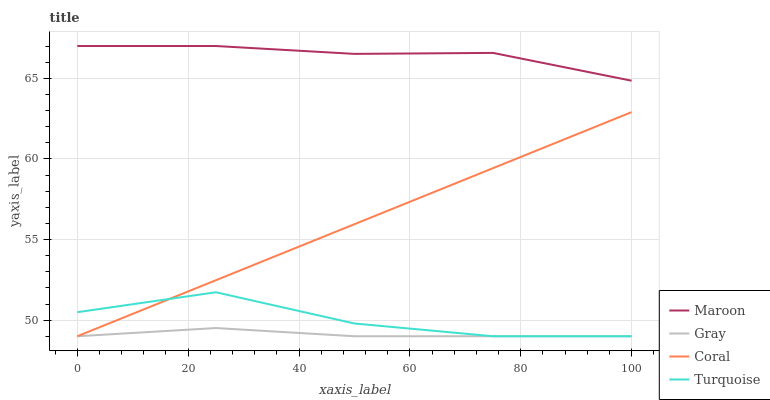Does Gray have the minimum area under the curve?
Answer yes or no. Yes. Does Maroon have the maximum area under the curve?
Answer yes or no. Yes. Does Coral have the minimum area under the curve?
Answer yes or no. No. Does Coral have the maximum area under the curve?
Answer yes or no. No. Is Coral the smoothest?
Answer yes or no. Yes. Is Turquoise the roughest?
Answer yes or no. Yes. Is Turquoise the smoothest?
Answer yes or no. No. Is Coral the roughest?
Answer yes or no. No. Does Maroon have the lowest value?
Answer yes or no. No. Does Maroon have the highest value?
Answer yes or no. Yes. Does Coral have the highest value?
Answer yes or no. No. Is Turquoise less than Maroon?
Answer yes or no. Yes. Is Maroon greater than Turquoise?
Answer yes or no. Yes. Does Gray intersect Coral?
Answer yes or no. Yes. Is Gray less than Coral?
Answer yes or no. No. Is Gray greater than Coral?
Answer yes or no. No. Does Turquoise intersect Maroon?
Answer yes or no. No. 